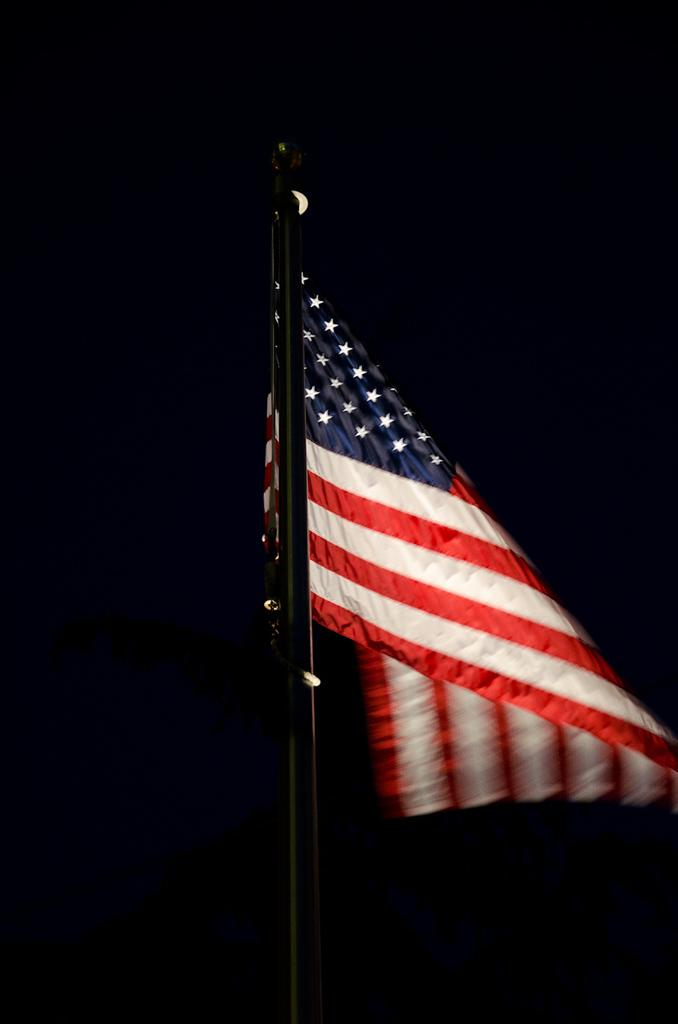What is the main object in the image? There is a flag of a country in the image. What is the flag attached to? The flag is attached to a pole. What can be observed about the background of the image? The background of the image is dark. How many cents are visible on the flag in the image? There are no cents present on the flag in the image. What type of learning material can be seen in the image? There is no learning material present in the image. 